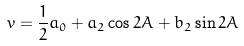Convert formula to latex. <formula><loc_0><loc_0><loc_500><loc_500>v = \frac { 1 } { 2 } a _ { 0 } + a _ { 2 } \cos 2 A + b _ { 2 } \sin 2 A</formula> 